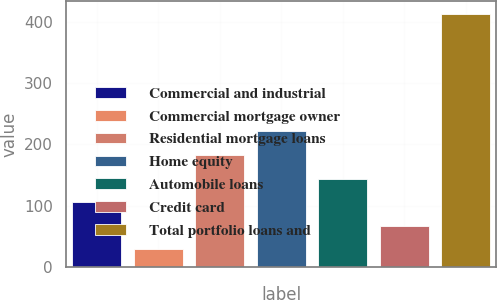Convert chart to OTSL. <chart><loc_0><loc_0><loc_500><loc_500><bar_chart><fcel>Commercial and industrial<fcel>Commercial mortgage owner<fcel>Residential mortgage loans<fcel>Home equity<fcel>Automobile loans<fcel>Credit card<fcel>Total portfolio loans and<nl><fcel>105.8<fcel>29<fcel>182.6<fcel>221<fcel>144.2<fcel>67.4<fcel>413<nl></chart> 